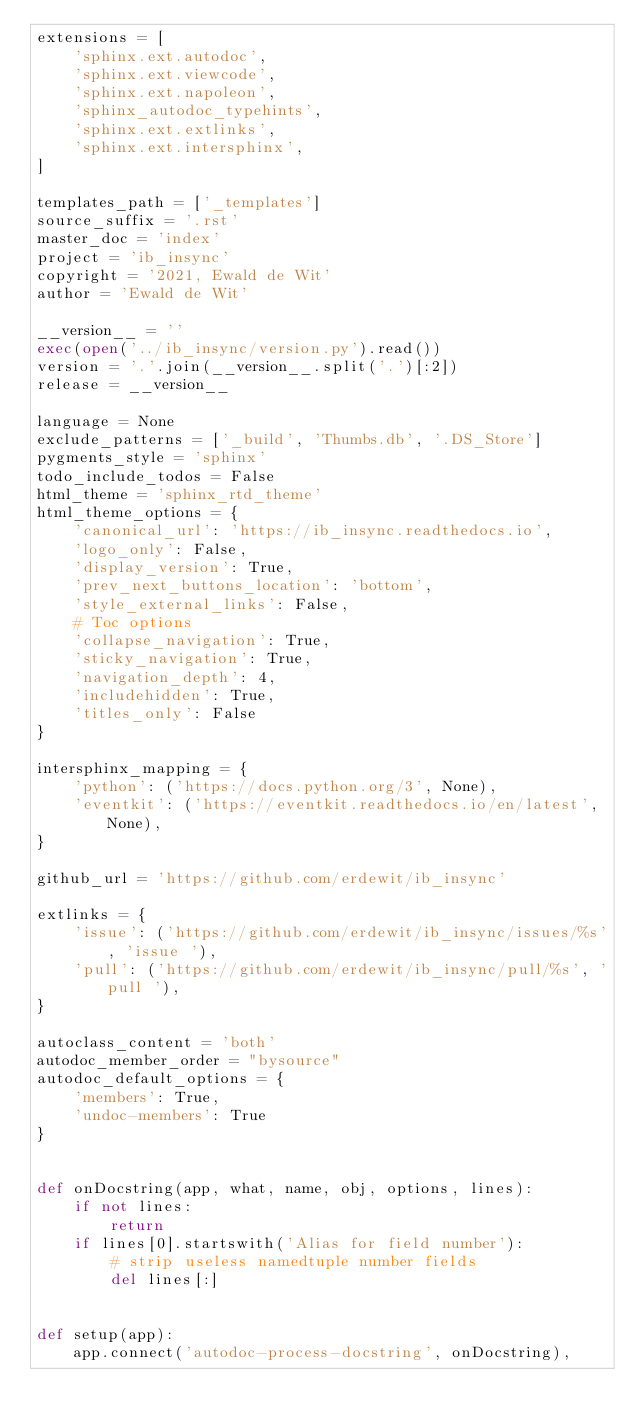Convert code to text. <code><loc_0><loc_0><loc_500><loc_500><_Python_>extensions = [
    'sphinx.ext.autodoc',
    'sphinx.ext.viewcode',
    'sphinx.ext.napoleon',
    'sphinx_autodoc_typehints',
    'sphinx.ext.extlinks',
    'sphinx.ext.intersphinx',
]

templates_path = ['_templates']
source_suffix = '.rst'
master_doc = 'index'
project = 'ib_insync'
copyright = '2021, Ewald de Wit'
author = 'Ewald de Wit'

__version__ = ''
exec(open('../ib_insync/version.py').read())
version = '.'.join(__version__.split('.')[:2])
release = __version__

language = None
exclude_patterns = ['_build', 'Thumbs.db', '.DS_Store']
pygments_style = 'sphinx'
todo_include_todos = False
html_theme = 'sphinx_rtd_theme'
html_theme_options = {
    'canonical_url': 'https://ib_insync.readthedocs.io',
    'logo_only': False,
    'display_version': True,
    'prev_next_buttons_location': 'bottom',
    'style_external_links': False,
    # Toc options
    'collapse_navigation': True,
    'sticky_navigation': True,
    'navigation_depth': 4,
    'includehidden': True,
    'titles_only': False
}

intersphinx_mapping = {
    'python': ('https://docs.python.org/3', None),
    'eventkit': ('https://eventkit.readthedocs.io/en/latest', None),
}

github_url = 'https://github.com/erdewit/ib_insync'

extlinks = {
    'issue': ('https://github.com/erdewit/ib_insync/issues/%s', 'issue '),
    'pull': ('https://github.com/erdewit/ib_insync/pull/%s', 'pull '),
}

autoclass_content = 'both'
autodoc_member_order = "bysource"
autodoc_default_options = {
    'members': True,
    'undoc-members': True
}


def onDocstring(app, what, name, obj, options, lines):
    if not lines:
        return
    if lines[0].startswith('Alias for field number'):
        # strip useless namedtuple number fields
        del lines[:]


def setup(app):
    app.connect('autodoc-process-docstring', onDocstring),
</code> 